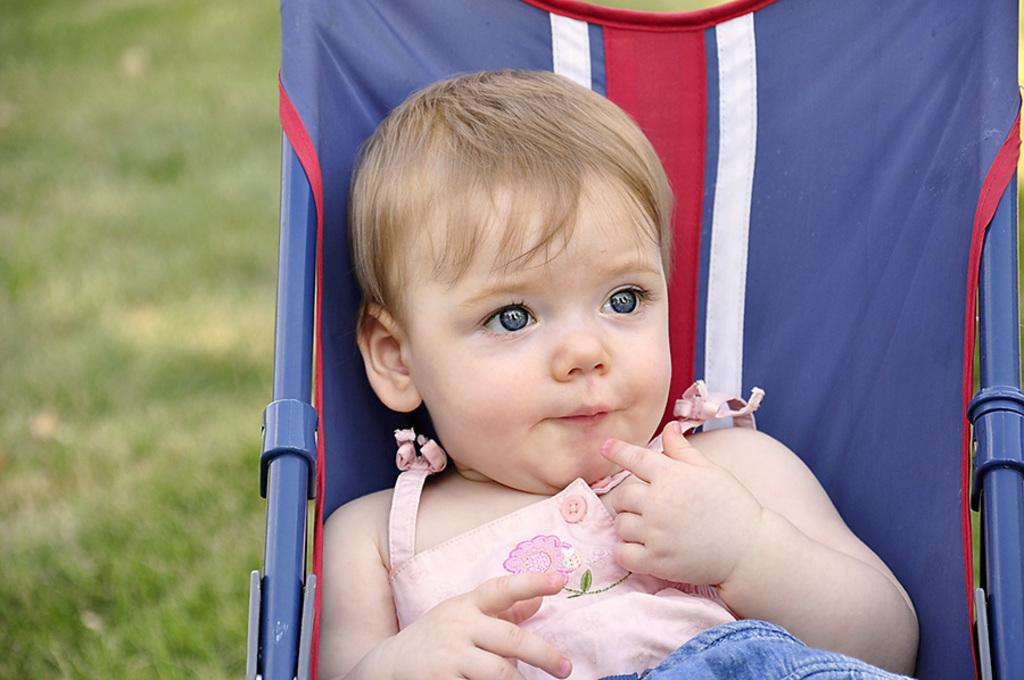What is the main subject of the image? There is a baby in the image. What is the baby doing in the image? The baby is sitting on a chair. What can be seen in the background of the image? There are trees in the background of the image. How would you describe the background of the image? The background is blurry. What type of curve can be seen in the harbor in the image? There is no harbor present in the image, so there is no curve to be seen. 